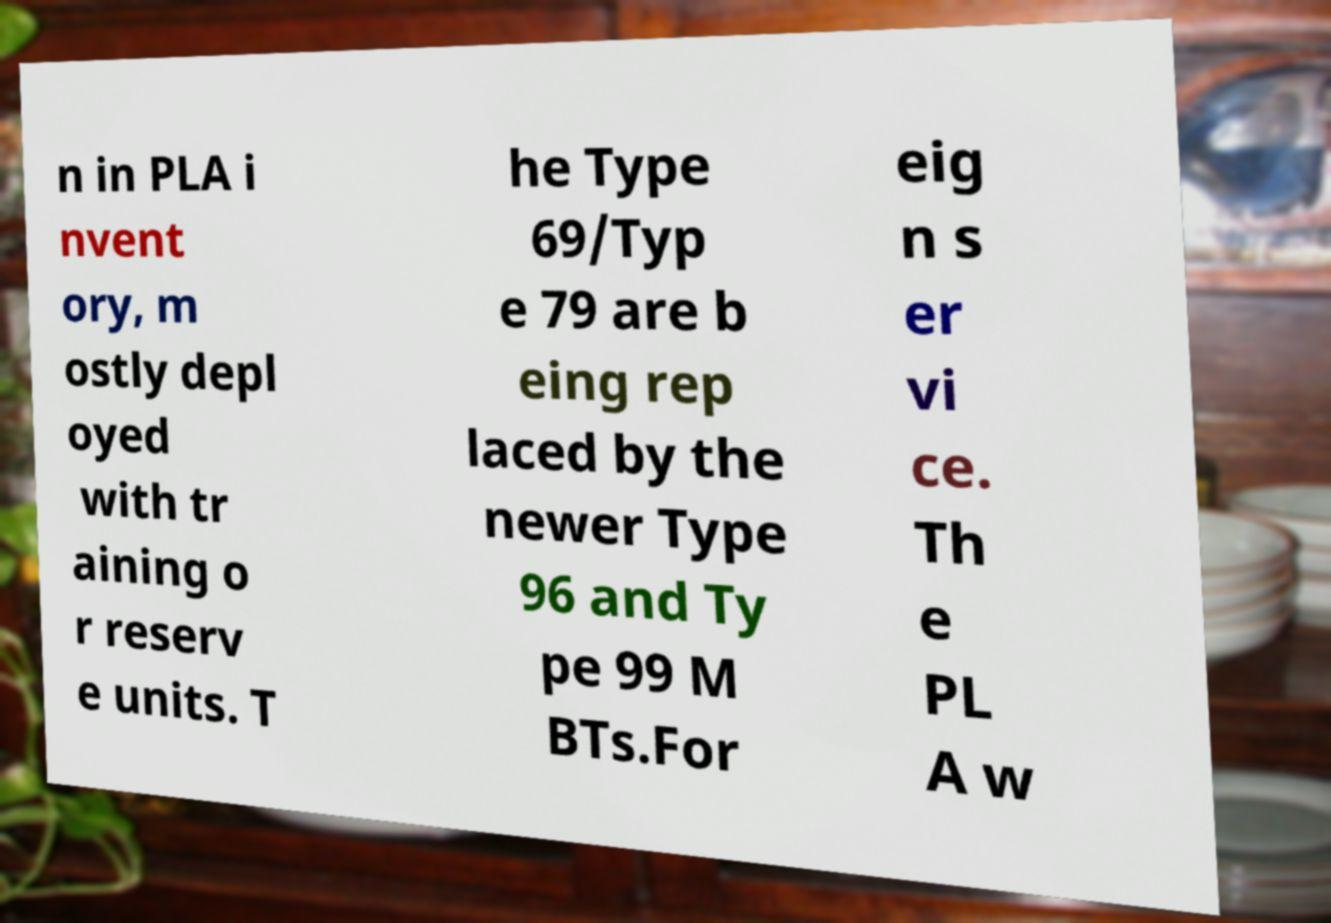I need the written content from this picture converted into text. Can you do that? n in PLA i nvent ory, m ostly depl oyed with tr aining o r reserv e units. T he Type 69/Typ e 79 are b eing rep laced by the newer Type 96 and Ty pe 99 M BTs.For eig n s er vi ce. Th e PL A w 